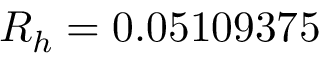<formula> <loc_0><loc_0><loc_500><loc_500>R _ { h } = 0 . 0 5 1 0 9 3 7 5</formula> 